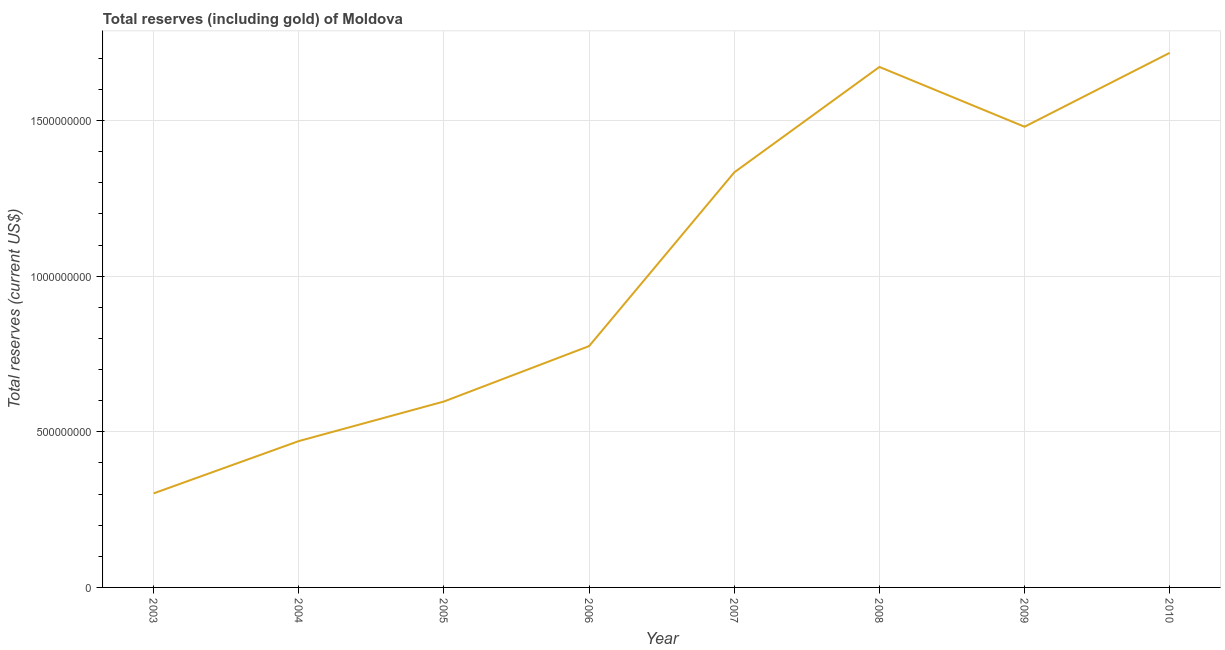What is the total reserves (including gold) in 2006?
Give a very brief answer. 7.75e+08. Across all years, what is the maximum total reserves (including gold)?
Your answer should be compact. 1.72e+09. Across all years, what is the minimum total reserves (including gold)?
Provide a short and direct response. 3.02e+08. What is the sum of the total reserves (including gold)?
Offer a very short reply. 8.35e+09. What is the difference between the total reserves (including gold) in 2007 and 2009?
Provide a succinct answer. -1.47e+08. What is the average total reserves (including gold) per year?
Offer a very short reply. 1.04e+09. What is the median total reserves (including gold)?
Make the answer very short. 1.05e+09. Do a majority of the years between 2004 and 2003 (inclusive) have total reserves (including gold) greater than 300000000 US$?
Provide a succinct answer. No. What is the ratio of the total reserves (including gold) in 2005 to that in 2007?
Keep it short and to the point. 0.45. Is the difference between the total reserves (including gold) in 2006 and 2008 greater than the difference between any two years?
Give a very brief answer. No. What is the difference between the highest and the second highest total reserves (including gold)?
Ensure brevity in your answer.  4.53e+07. Is the sum of the total reserves (including gold) in 2007 and 2010 greater than the maximum total reserves (including gold) across all years?
Keep it short and to the point. Yes. What is the difference between the highest and the lowest total reserves (including gold)?
Provide a short and direct response. 1.42e+09. How many lines are there?
Ensure brevity in your answer.  1. How many years are there in the graph?
Keep it short and to the point. 8. Are the values on the major ticks of Y-axis written in scientific E-notation?
Ensure brevity in your answer.  No. Does the graph contain grids?
Make the answer very short. Yes. What is the title of the graph?
Make the answer very short. Total reserves (including gold) of Moldova. What is the label or title of the Y-axis?
Ensure brevity in your answer.  Total reserves (current US$). What is the Total reserves (current US$) in 2003?
Your answer should be very brief. 3.02e+08. What is the Total reserves (current US$) in 2004?
Offer a terse response. 4.70e+08. What is the Total reserves (current US$) in 2005?
Offer a very short reply. 5.97e+08. What is the Total reserves (current US$) in 2006?
Offer a terse response. 7.75e+08. What is the Total reserves (current US$) of 2007?
Your response must be concise. 1.33e+09. What is the Total reserves (current US$) of 2008?
Your answer should be compact. 1.67e+09. What is the Total reserves (current US$) of 2009?
Make the answer very short. 1.48e+09. What is the Total reserves (current US$) in 2010?
Ensure brevity in your answer.  1.72e+09. What is the difference between the Total reserves (current US$) in 2003 and 2004?
Offer a terse response. -1.68e+08. What is the difference between the Total reserves (current US$) in 2003 and 2005?
Make the answer very short. -2.95e+08. What is the difference between the Total reserves (current US$) in 2003 and 2006?
Ensure brevity in your answer.  -4.73e+08. What is the difference between the Total reserves (current US$) in 2003 and 2007?
Ensure brevity in your answer.  -1.03e+09. What is the difference between the Total reserves (current US$) in 2003 and 2008?
Provide a succinct answer. -1.37e+09. What is the difference between the Total reserves (current US$) in 2003 and 2009?
Provide a short and direct response. -1.18e+09. What is the difference between the Total reserves (current US$) in 2003 and 2010?
Make the answer very short. -1.42e+09. What is the difference between the Total reserves (current US$) in 2004 and 2005?
Your response must be concise. -1.27e+08. What is the difference between the Total reserves (current US$) in 2004 and 2006?
Provide a succinct answer. -3.05e+08. What is the difference between the Total reserves (current US$) in 2004 and 2007?
Make the answer very short. -8.63e+08. What is the difference between the Total reserves (current US$) in 2004 and 2008?
Offer a very short reply. -1.20e+09. What is the difference between the Total reserves (current US$) in 2004 and 2009?
Offer a terse response. -1.01e+09. What is the difference between the Total reserves (current US$) in 2004 and 2010?
Your response must be concise. -1.25e+09. What is the difference between the Total reserves (current US$) in 2005 and 2006?
Ensure brevity in your answer.  -1.78e+08. What is the difference between the Total reserves (current US$) in 2005 and 2007?
Ensure brevity in your answer.  -7.36e+08. What is the difference between the Total reserves (current US$) in 2005 and 2008?
Offer a very short reply. -1.07e+09. What is the difference between the Total reserves (current US$) in 2005 and 2009?
Give a very brief answer. -8.83e+08. What is the difference between the Total reserves (current US$) in 2005 and 2010?
Offer a very short reply. -1.12e+09. What is the difference between the Total reserves (current US$) in 2006 and 2007?
Give a very brief answer. -5.58e+08. What is the difference between the Total reserves (current US$) in 2006 and 2008?
Give a very brief answer. -8.97e+08. What is the difference between the Total reserves (current US$) in 2006 and 2009?
Ensure brevity in your answer.  -7.05e+08. What is the difference between the Total reserves (current US$) in 2006 and 2010?
Offer a very short reply. -9.42e+08. What is the difference between the Total reserves (current US$) in 2007 and 2008?
Give a very brief answer. -3.39e+08. What is the difference between the Total reserves (current US$) in 2007 and 2009?
Keep it short and to the point. -1.47e+08. What is the difference between the Total reserves (current US$) in 2007 and 2010?
Give a very brief answer. -3.84e+08. What is the difference between the Total reserves (current US$) in 2008 and 2009?
Provide a succinct answer. 1.92e+08. What is the difference between the Total reserves (current US$) in 2008 and 2010?
Your response must be concise. -4.53e+07. What is the difference between the Total reserves (current US$) in 2009 and 2010?
Your response must be concise. -2.37e+08. What is the ratio of the Total reserves (current US$) in 2003 to that in 2004?
Your response must be concise. 0.64. What is the ratio of the Total reserves (current US$) in 2003 to that in 2005?
Provide a short and direct response. 0.51. What is the ratio of the Total reserves (current US$) in 2003 to that in 2006?
Your answer should be very brief. 0.39. What is the ratio of the Total reserves (current US$) in 2003 to that in 2007?
Offer a terse response. 0.23. What is the ratio of the Total reserves (current US$) in 2003 to that in 2008?
Provide a short and direct response. 0.18. What is the ratio of the Total reserves (current US$) in 2003 to that in 2009?
Keep it short and to the point. 0.2. What is the ratio of the Total reserves (current US$) in 2003 to that in 2010?
Give a very brief answer. 0.18. What is the ratio of the Total reserves (current US$) in 2004 to that in 2005?
Ensure brevity in your answer.  0.79. What is the ratio of the Total reserves (current US$) in 2004 to that in 2006?
Provide a short and direct response. 0.61. What is the ratio of the Total reserves (current US$) in 2004 to that in 2007?
Provide a short and direct response. 0.35. What is the ratio of the Total reserves (current US$) in 2004 to that in 2008?
Give a very brief answer. 0.28. What is the ratio of the Total reserves (current US$) in 2004 to that in 2009?
Your answer should be very brief. 0.32. What is the ratio of the Total reserves (current US$) in 2004 to that in 2010?
Your answer should be very brief. 0.27. What is the ratio of the Total reserves (current US$) in 2005 to that in 2006?
Your response must be concise. 0.77. What is the ratio of the Total reserves (current US$) in 2005 to that in 2007?
Your answer should be very brief. 0.45. What is the ratio of the Total reserves (current US$) in 2005 to that in 2008?
Your response must be concise. 0.36. What is the ratio of the Total reserves (current US$) in 2005 to that in 2009?
Keep it short and to the point. 0.4. What is the ratio of the Total reserves (current US$) in 2005 to that in 2010?
Your response must be concise. 0.35. What is the ratio of the Total reserves (current US$) in 2006 to that in 2007?
Give a very brief answer. 0.58. What is the ratio of the Total reserves (current US$) in 2006 to that in 2008?
Ensure brevity in your answer.  0.46. What is the ratio of the Total reserves (current US$) in 2006 to that in 2009?
Your response must be concise. 0.52. What is the ratio of the Total reserves (current US$) in 2006 to that in 2010?
Give a very brief answer. 0.45. What is the ratio of the Total reserves (current US$) in 2007 to that in 2008?
Keep it short and to the point. 0.8. What is the ratio of the Total reserves (current US$) in 2007 to that in 2009?
Make the answer very short. 0.9. What is the ratio of the Total reserves (current US$) in 2007 to that in 2010?
Provide a short and direct response. 0.78. What is the ratio of the Total reserves (current US$) in 2008 to that in 2009?
Your response must be concise. 1.13. What is the ratio of the Total reserves (current US$) in 2008 to that in 2010?
Your response must be concise. 0.97. What is the ratio of the Total reserves (current US$) in 2009 to that in 2010?
Keep it short and to the point. 0.86. 